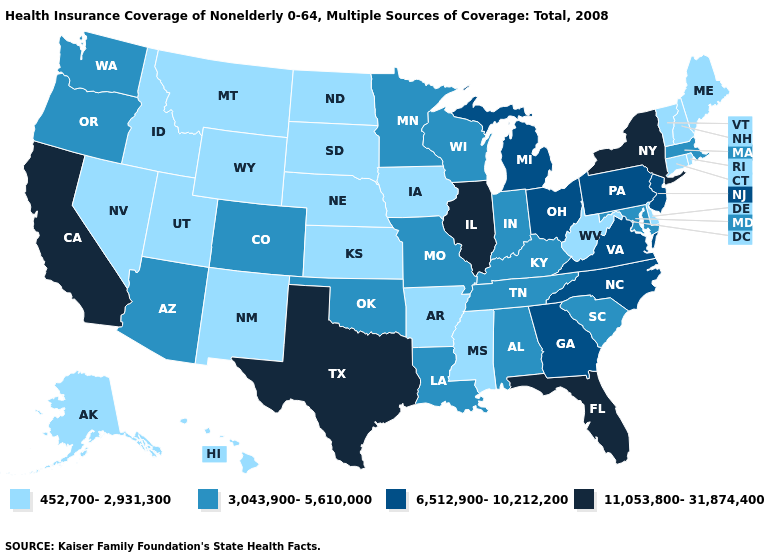Does Vermont have the highest value in the Northeast?
Short answer required. No. Name the states that have a value in the range 3,043,900-5,610,000?
Concise answer only. Alabama, Arizona, Colorado, Indiana, Kentucky, Louisiana, Maryland, Massachusetts, Minnesota, Missouri, Oklahoma, Oregon, South Carolina, Tennessee, Washington, Wisconsin. Name the states that have a value in the range 11,053,800-31,874,400?
Quick response, please. California, Florida, Illinois, New York, Texas. Among the states that border New York , which have the lowest value?
Answer briefly. Connecticut, Vermont. Does the map have missing data?
Quick response, please. No. Does the map have missing data?
Answer briefly. No. Does Ohio have the same value as Pennsylvania?
Keep it brief. Yes. What is the value of Georgia?
Be succinct. 6,512,900-10,212,200. Name the states that have a value in the range 452,700-2,931,300?
Concise answer only. Alaska, Arkansas, Connecticut, Delaware, Hawaii, Idaho, Iowa, Kansas, Maine, Mississippi, Montana, Nebraska, Nevada, New Hampshire, New Mexico, North Dakota, Rhode Island, South Dakota, Utah, Vermont, West Virginia, Wyoming. Does New Jersey have the lowest value in the Northeast?
Concise answer only. No. Does Mississippi have the lowest value in the USA?
Be succinct. Yes. Name the states that have a value in the range 3,043,900-5,610,000?
Quick response, please. Alabama, Arizona, Colorado, Indiana, Kentucky, Louisiana, Maryland, Massachusetts, Minnesota, Missouri, Oklahoma, Oregon, South Carolina, Tennessee, Washington, Wisconsin. What is the value of Nevada?
Answer briefly. 452,700-2,931,300. Name the states that have a value in the range 6,512,900-10,212,200?
Answer briefly. Georgia, Michigan, New Jersey, North Carolina, Ohio, Pennsylvania, Virginia. Which states have the lowest value in the USA?
Concise answer only. Alaska, Arkansas, Connecticut, Delaware, Hawaii, Idaho, Iowa, Kansas, Maine, Mississippi, Montana, Nebraska, Nevada, New Hampshire, New Mexico, North Dakota, Rhode Island, South Dakota, Utah, Vermont, West Virginia, Wyoming. 